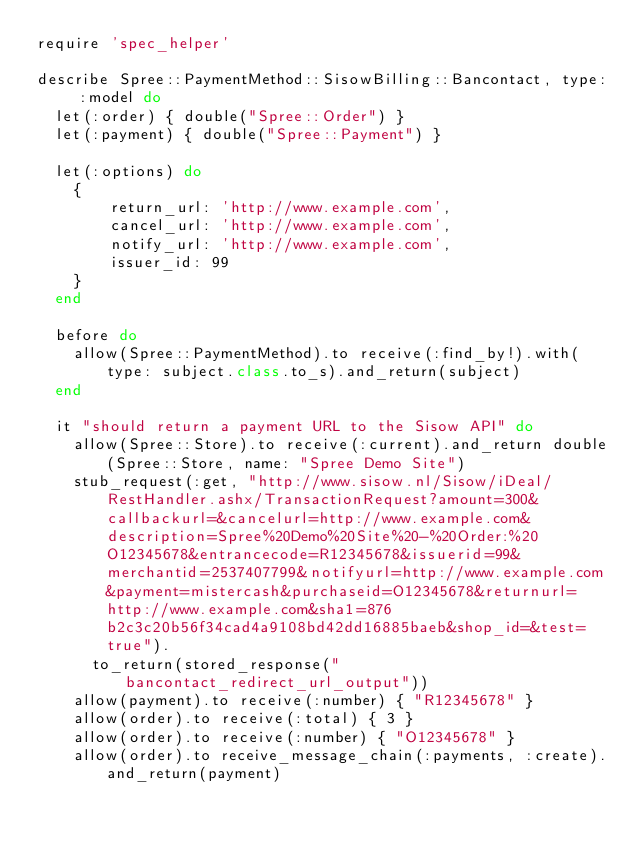Convert code to text. <code><loc_0><loc_0><loc_500><loc_500><_Ruby_>require 'spec_helper'

describe Spree::PaymentMethod::SisowBilling::Bancontact, type: :model do
  let(:order) { double("Spree::Order") }
  let(:payment) { double("Spree::Payment") }

  let(:options) do
    {
        return_url: 'http://www.example.com',
        cancel_url: 'http://www.example.com',
        notify_url: 'http://www.example.com',
        issuer_id: 99
    }
  end

  before do
    allow(Spree::PaymentMethod).to receive(:find_by!).with(type: subject.class.to_s).and_return(subject)
  end

  it "should return a payment URL to the Sisow API" do
    allow(Spree::Store).to receive(:current).and_return double(Spree::Store, name: "Spree Demo Site")
    stub_request(:get, "http://www.sisow.nl/Sisow/iDeal/RestHandler.ashx/TransactionRequest?amount=300&callbackurl=&cancelurl=http://www.example.com&description=Spree%20Demo%20Site%20-%20Order:%20O12345678&entrancecode=R12345678&issuerid=99&merchantid=2537407799&notifyurl=http://www.example.com&payment=mistercash&purchaseid=O12345678&returnurl=http://www.example.com&sha1=876b2c3c20b56f34cad4a9108bd42dd16885baeb&shop_id=&test=true").
      to_return(stored_response("bancontact_redirect_url_output"))
    allow(payment).to receive(:number) { "R12345678" }
    allow(order).to receive(:total) { 3 }
    allow(order).to receive(:number) { "O12345678" }
    allow(order).to receive_message_chain(:payments, :create).and_return(payment)
</code> 